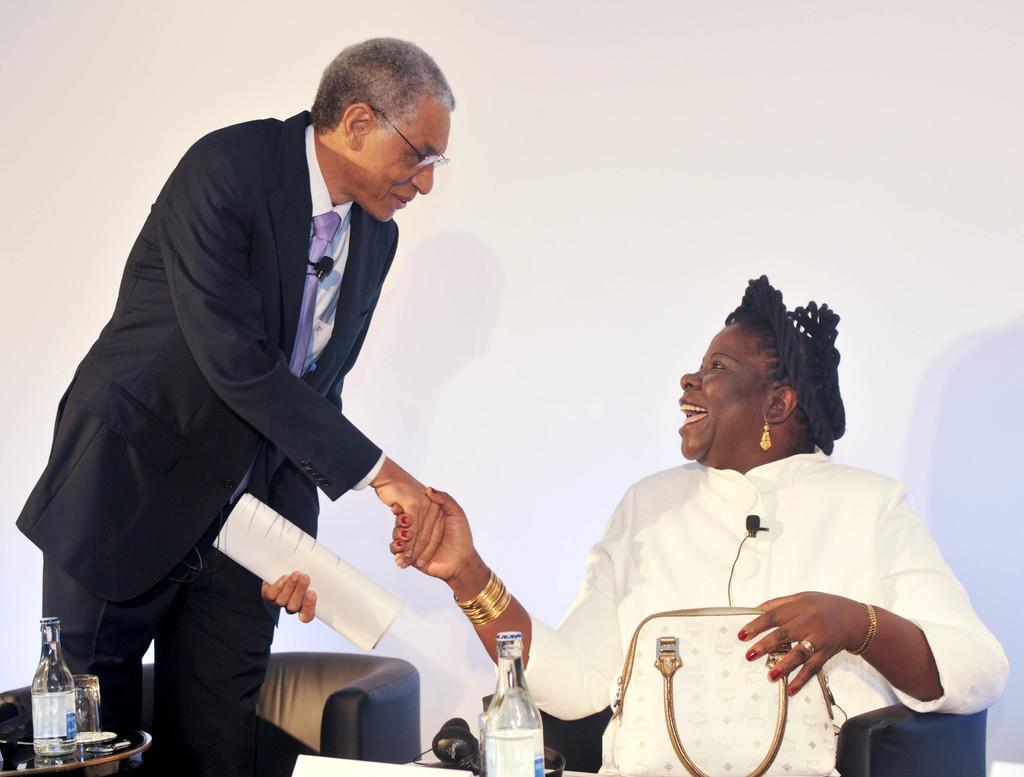How would you summarize this image in a sentence or two? Woman sitting on the chair and on the table we have bottle,headphones and a man standing holding paper. 